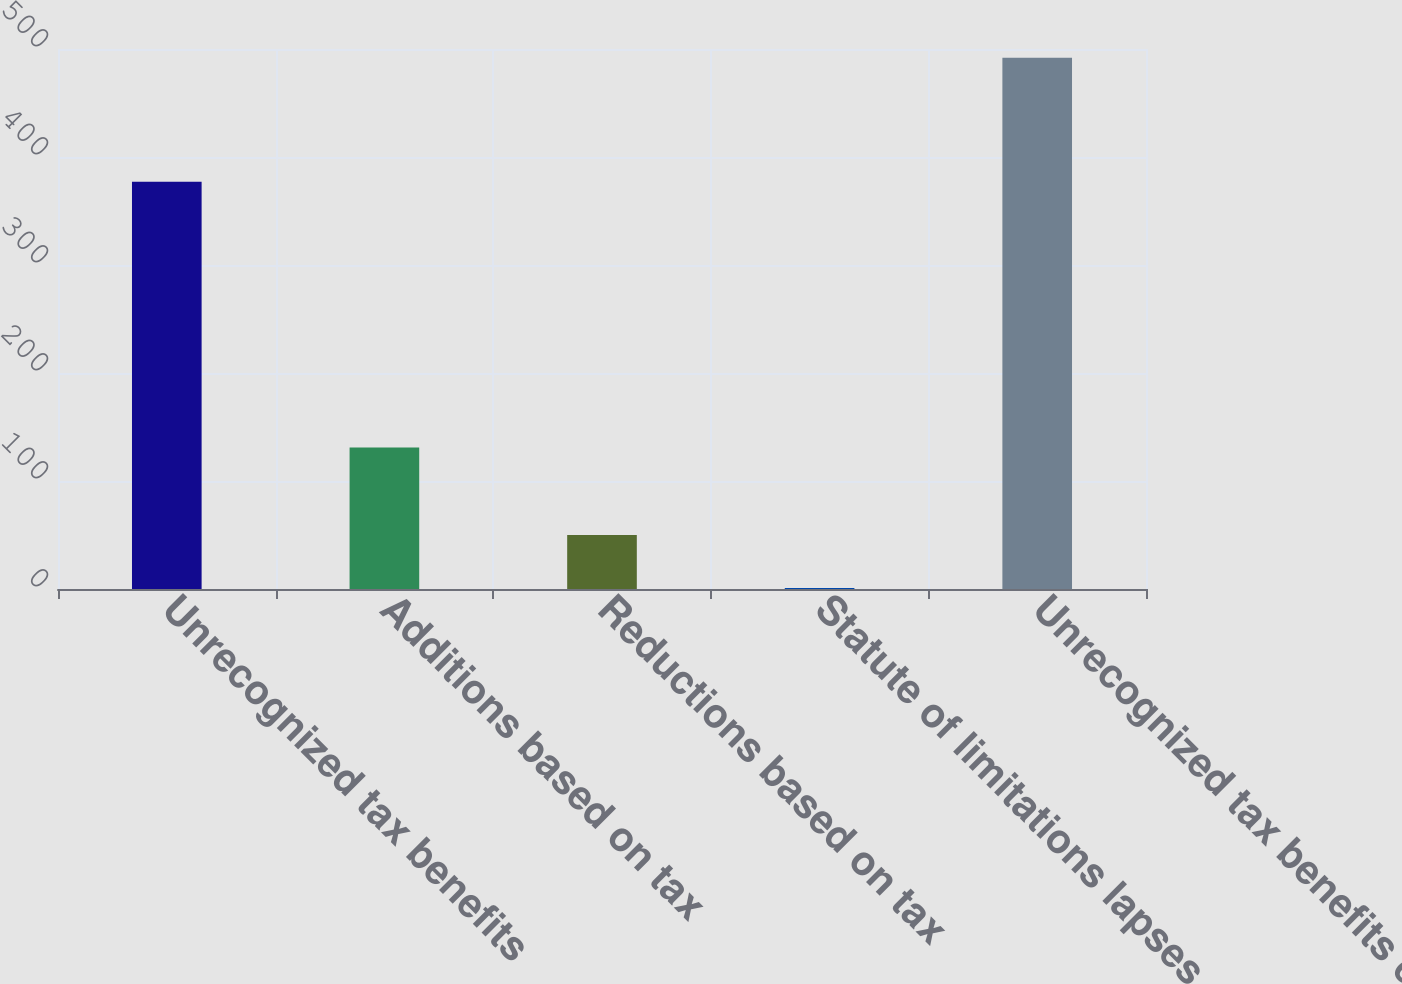Convert chart to OTSL. <chart><loc_0><loc_0><loc_500><loc_500><bar_chart><fcel>Unrecognized tax benefits<fcel>Additions based on tax<fcel>Reductions based on tax<fcel>Statute of limitations lapses<fcel>Unrecognized tax benefits end<nl><fcel>377<fcel>131<fcel>50.1<fcel>1<fcel>492<nl></chart> 